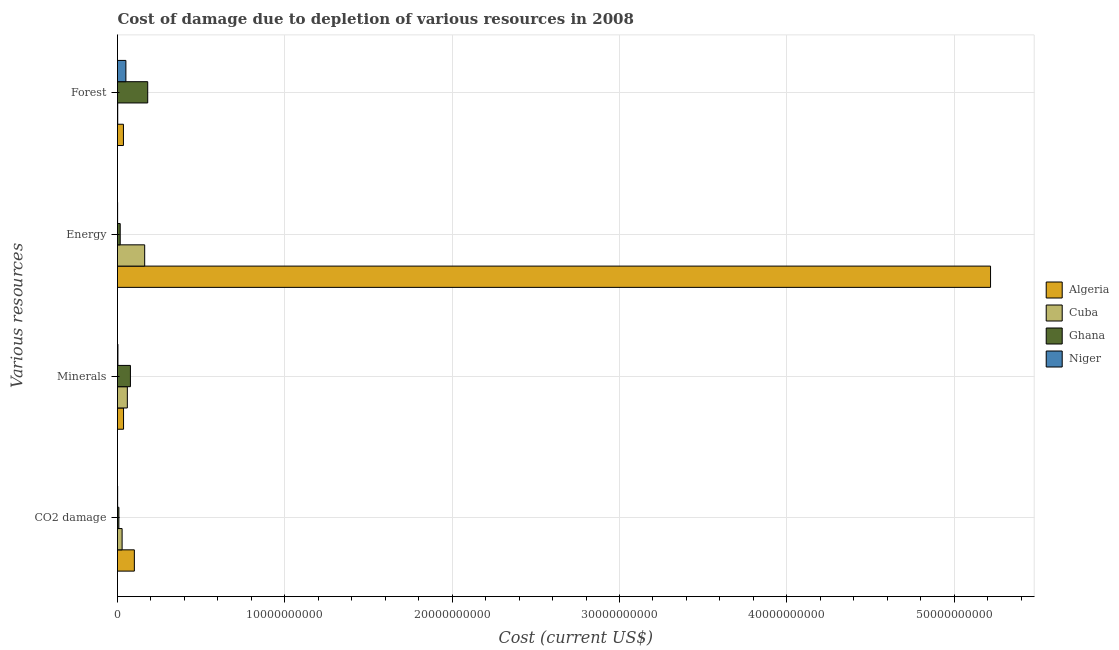How many different coloured bars are there?
Provide a succinct answer. 4. How many groups of bars are there?
Make the answer very short. 4. Are the number of bars on each tick of the Y-axis equal?
Your answer should be compact. Yes. How many bars are there on the 1st tick from the top?
Offer a terse response. 4. How many bars are there on the 2nd tick from the bottom?
Ensure brevity in your answer.  4. What is the label of the 2nd group of bars from the top?
Your answer should be very brief. Energy. What is the cost of damage due to depletion of coal in Algeria?
Provide a short and direct response. 1.01e+09. Across all countries, what is the maximum cost of damage due to depletion of energy?
Your response must be concise. 5.22e+1. Across all countries, what is the minimum cost of damage due to depletion of forests?
Your answer should be compact. 1.25e+07. In which country was the cost of damage due to depletion of energy maximum?
Offer a terse response. Algeria. In which country was the cost of damage due to depletion of energy minimum?
Offer a very short reply. Niger. What is the total cost of damage due to depletion of minerals in the graph?
Offer a very short reply. 1.75e+09. What is the difference between the cost of damage due to depletion of coal in Ghana and that in Cuba?
Provide a short and direct response. -1.92e+08. What is the difference between the cost of damage due to depletion of minerals in Ghana and the cost of damage due to depletion of energy in Niger?
Your answer should be compact. 7.66e+08. What is the average cost of damage due to depletion of minerals per country?
Give a very brief answer. 4.37e+08. What is the difference between the cost of damage due to depletion of minerals and cost of damage due to depletion of forests in Niger?
Give a very brief answer. -4.75e+08. In how many countries, is the cost of damage due to depletion of coal greater than 12000000000 US$?
Your answer should be compact. 0. What is the ratio of the cost of damage due to depletion of minerals in Algeria to that in Niger?
Give a very brief answer. 14.01. Is the cost of damage due to depletion of energy in Cuba less than that in Ghana?
Give a very brief answer. No. What is the difference between the highest and the second highest cost of damage due to depletion of forests?
Your answer should be very brief. 1.30e+09. What is the difference between the highest and the lowest cost of damage due to depletion of forests?
Offer a terse response. 1.79e+09. In how many countries, is the cost of damage due to depletion of minerals greater than the average cost of damage due to depletion of minerals taken over all countries?
Give a very brief answer. 2. Is the sum of the cost of damage due to depletion of coal in Ghana and Cuba greater than the maximum cost of damage due to depletion of energy across all countries?
Ensure brevity in your answer.  No. Is it the case that in every country, the sum of the cost of damage due to depletion of forests and cost of damage due to depletion of energy is greater than the sum of cost of damage due to depletion of minerals and cost of damage due to depletion of coal?
Your answer should be very brief. Yes. What does the 2nd bar from the top in CO2 damage represents?
Make the answer very short. Ghana. What does the 4th bar from the bottom in Minerals represents?
Provide a short and direct response. Niger. Is it the case that in every country, the sum of the cost of damage due to depletion of coal and cost of damage due to depletion of minerals is greater than the cost of damage due to depletion of energy?
Your response must be concise. No. How many countries are there in the graph?
Provide a succinct answer. 4. What is the difference between two consecutive major ticks on the X-axis?
Your answer should be very brief. 1.00e+1. Are the values on the major ticks of X-axis written in scientific E-notation?
Your answer should be compact. No. Does the graph contain any zero values?
Your answer should be very brief. No. Does the graph contain grids?
Offer a very short reply. Yes. Where does the legend appear in the graph?
Your answer should be compact. Center right. What is the title of the graph?
Offer a terse response. Cost of damage due to depletion of various resources in 2008 . What is the label or title of the X-axis?
Your response must be concise. Cost (current US$). What is the label or title of the Y-axis?
Ensure brevity in your answer.  Various resources. What is the Cost (current US$) in Algeria in CO2 damage?
Your answer should be compact. 1.01e+09. What is the Cost (current US$) of Cuba in CO2 damage?
Keep it short and to the point. 2.75e+08. What is the Cost (current US$) of Ghana in CO2 damage?
Provide a short and direct response. 8.25e+07. What is the Cost (current US$) of Niger in CO2 damage?
Offer a terse response. 8.27e+06. What is the Cost (current US$) of Algeria in Minerals?
Give a very brief answer. 3.61e+08. What is the Cost (current US$) in Cuba in Minerals?
Your answer should be very brief. 5.88e+08. What is the Cost (current US$) of Ghana in Minerals?
Your answer should be compact. 7.72e+08. What is the Cost (current US$) in Niger in Minerals?
Give a very brief answer. 2.58e+07. What is the Cost (current US$) of Algeria in Energy?
Provide a short and direct response. 5.22e+1. What is the Cost (current US$) of Cuba in Energy?
Your answer should be very brief. 1.62e+09. What is the Cost (current US$) of Ghana in Energy?
Provide a short and direct response. 1.61e+08. What is the Cost (current US$) of Niger in Energy?
Ensure brevity in your answer.  6.09e+06. What is the Cost (current US$) of Algeria in Forest?
Your response must be concise. 3.55e+08. What is the Cost (current US$) of Cuba in Forest?
Ensure brevity in your answer.  1.25e+07. What is the Cost (current US$) in Ghana in Forest?
Keep it short and to the point. 1.81e+09. What is the Cost (current US$) in Niger in Forest?
Your answer should be compact. 5.01e+08. Across all Various resources, what is the maximum Cost (current US$) of Algeria?
Your answer should be compact. 5.22e+1. Across all Various resources, what is the maximum Cost (current US$) in Cuba?
Provide a succinct answer. 1.62e+09. Across all Various resources, what is the maximum Cost (current US$) in Ghana?
Give a very brief answer. 1.81e+09. Across all Various resources, what is the maximum Cost (current US$) of Niger?
Ensure brevity in your answer.  5.01e+08. Across all Various resources, what is the minimum Cost (current US$) in Algeria?
Offer a very short reply. 3.55e+08. Across all Various resources, what is the minimum Cost (current US$) of Cuba?
Your answer should be very brief. 1.25e+07. Across all Various resources, what is the minimum Cost (current US$) in Ghana?
Your answer should be very brief. 8.25e+07. Across all Various resources, what is the minimum Cost (current US$) in Niger?
Offer a terse response. 6.09e+06. What is the total Cost (current US$) in Algeria in the graph?
Offer a very short reply. 5.39e+1. What is the total Cost (current US$) of Cuba in the graph?
Provide a succinct answer. 2.50e+09. What is the total Cost (current US$) of Ghana in the graph?
Keep it short and to the point. 2.82e+09. What is the total Cost (current US$) in Niger in the graph?
Make the answer very short. 5.41e+08. What is the difference between the Cost (current US$) of Algeria in CO2 damage and that in Minerals?
Your answer should be compact. 6.46e+08. What is the difference between the Cost (current US$) of Cuba in CO2 damage and that in Minerals?
Your response must be concise. -3.13e+08. What is the difference between the Cost (current US$) in Ghana in CO2 damage and that in Minerals?
Offer a very short reply. -6.90e+08. What is the difference between the Cost (current US$) of Niger in CO2 damage and that in Minerals?
Offer a very short reply. -1.75e+07. What is the difference between the Cost (current US$) of Algeria in CO2 damage and that in Energy?
Your answer should be very brief. -5.12e+1. What is the difference between the Cost (current US$) in Cuba in CO2 damage and that in Energy?
Your answer should be very brief. -1.35e+09. What is the difference between the Cost (current US$) of Ghana in CO2 damage and that in Energy?
Provide a succinct answer. -7.87e+07. What is the difference between the Cost (current US$) of Niger in CO2 damage and that in Energy?
Offer a very short reply. 2.19e+06. What is the difference between the Cost (current US$) in Algeria in CO2 damage and that in Forest?
Ensure brevity in your answer.  6.52e+08. What is the difference between the Cost (current US$) of Cuba in CO2 damage and that in Forest?
Ensure brevity in your answer.  2.62e+08. What is the difference between the Cost (current US$) of Ghana in CO2 damage and that in Forest?
Offer a very short reply. -1.72e+09. What is the difference between the Cost (current US$) of Niger in CO2 damage and that in Forest?
Your answer should be very brief. -4.93e+08. What is the difference between the Cost (current US$) in Algeria in Minerals and that in Energy?
Ensure brevity in your answer.  -5.18e+1. What is the difference between the Cost (current US$) of Cuba in Minerals and that in Energy?
Your response must be concise. -1.04e+09. What is the difference between the Cost (current US$) in Ghana in Minerals and that in Energy?
Provide a succinct answer. 6.11e+08. What is the difference between the Cost (current US$) of Niger in Minerals and that in Energy?
Your answer should be very brief. 1.97e+07. What is the difference between the Cost (current US$) in Algeria in Minerals and that in Forest?
Ensure brevity in your answer.  6.58e+06. What is the difference between the Cost (current US$) in Cuba in Minerals and that in Forest?
Make the answer very short. 5.75e+08. What is the difference between the Cost (current US$) in Ghana in Minerals and that in Forest?
Offer a very short reply. -1.03e+09. What is the difference between the Cost (current US$) of Niger in Minerals and that in Forest?
Provide a short and direct response. -4.75e+08. What is the difference between the Cost (current US$) in Algeria in Energy and that in Forest?
Your response must be concise. 5.18e+1. What is the difference between the Cost (current US$) in Cuba in Energy and that in Forest?
Give a very brief answer. 1.61e+09. What is the difference between the Cost (current US$) of Ghana in Energy and that in Forest?
Ensure brevity in your answer.  -1.64e+09. What is the difference between the Cost (current US$) of Niger in Energy and that in Forest?
Make the answer very short. -4.95e+08. What is the difference between the Cost (current US$) in Algeria in CO2 damage and the Cost (current US$) in Cuba in Minerals?
Your answer should be compact. 4.19e+08. What is the difference between the Cost (current US$) in Algeria in CO2 damage and the Cost (current US$) in Ghana in Minerals?
Offer a terse response. 2.34e+08. What is the difference between the Cost (current US$) of Algeria in CO2 damage and the Cost (current US$) of Niger in Minerals?
Provide a short and direct response. 9.81e+08. What is the difference between the Cost (current US$) of Cuba in CO2 damage and the Cost (current US$) of Ghana in Minerals?
Offer a terse response. -4.98e+08. What is the difference between the Cost (current US$) of Cuba in CO2 damage and the Cost (current US$) of Niger in Minerals?
Give a very brief answer. 2.49e+08. What is the difference between the Cost (current US$) in Ghana in CO2 damage and the Cost (current US$) in Niger in Minerals?
Your answer should be very brief. 5.67e+07. What is the difference between the Cost (current US$) in Algeria in CO2 damage and the Cost (current US$) in Cuba in Energy?
Ensure brevity in your answer.  -6.18e+08. What is the difference between the Cost (current US$) of Algeria in CO2 damage and the Cost (current US$) of Ghana in Energy?
Provide a succinct answer. 8.46e+08. What is the difference between the Cost (current US$) in Algeria in CO2 damage and the Cost (current US$) in Niger in Energy?
Make the answer very short. 1.00e+09. What is the difference between the Cost (current US$) of Cuba in CO2 damage and the Cost (current US$) of Ghana in Energy?
Provide a short and direct response. 1.14e+08. What is the difference between the Cost (current US$) in Cuba in CO2 damage and the Cost (current US$) in Niger in Energy?
Keep it short and to the point. 2.69e+08. What is the difference between the Cost (current US$) of Ghana in CO2 damage and the Cost (current US$) of Niger in Energy?
Keep it short and to the point. 7.64e+07. What is the difference between the Cost (current US$) of Algeria in CO2 damage and the Cost (current US$) of Cuba in Forest?
Keep it short and to the point. 9.94e+08. What is the difference between the Cost (current US$) of Algeria in CO2 damage and the Cost (current US$) of Ghana in Forest?
Your answer should be very brief. -7.99e+08. What is the difference between the Cost (current US$) in Algeria in CO2 damage and the Cost (current US$) in Niger in Forest?
Offer a very short reply. 5.06e+08. What is the difference between the Cost (current US$) of Cuba in CO2 damage and the Cost (current US$) of Ghana in Forest?
Provide a succinct answer. -1.53e+09. What is the difference between the Cost (current US$) of Cuba in CO2 damage and the Cost (current US$) of Niger in Forest?
Provide a short and direct response. -2.26e+08. What is the difference between the Cost (current US$) of Ghana in CO2 damage and the Cost (current US$) of Niger in Forest?
Keep it short and to the point. -4.18e+08. What is the difference between the Cost (current US$) of Algeria in Minerals and the Cost (current US$) of Cuba in Energy?
Your response must be concise. -1.26e+09. What is the difference between the Cost (current US$) in Algeria in Minerals and the Cost (current US$) in Ghana in Energy?
Provide a short and direct response. 2.00e+08. What is the difference between the Cost (current US$) of Algeria in Minerals and the Cost (current US$) of Niger in Energy?
Provide a short and direct response. 3.55e+08. What is the difference between the Cost (current US$) of Cuba in Minerals and the Cost (current US$) of Ghana in Energy?
Your response must be concise. 4.27e+08. What is the difference between the Cost (current US$) in Cuba in Minerals and the Cost (current US$) in Niger in Energy?
Your answer should be very brief. 5.82e+08. What is the difference between the Cost (current US$) of Ghana in Minerals and the Cost (current US$) of Niger in Energy?
Provide a short and direct response. 7.66e+08. What is the difference between the Cost (current US$) of Algeria in Minerals and the Cost (current US$) of Cuba in Forest?
Your answer should be very brief. 3.49e+08. What is the difference between the Cost (current US$) of Algeria in Minerals and the Cost (current US$) of Ghana in Forest?
Keep it short and to the point. -1.44e+09. What is the difference between the Cost (current US$) of Algeria in Minerals and the Cost (current US$) of Niger in Forest?
Provide a succinct answer. -1.40e+08. What is the difference between the Cost (current US$) in Cuba in Minerals and the Cost (current US$) in Ghana in Forest?
Your answer should be compact. -1.22e+09. What is the difference between the Cost (current US$) of Cuba in Minerals and the Cost (current US$) of Niger in Forest?
Give a very brief answer. 8.70e+07. What is the difference between the Cost (current US$) of Ghana in Minerals and the Cost (current US$) of Niger in Forest?
Provide a short and direct response. 2.72e+08. What is the difference between the Cost (current US$) in Algeria in Energy and the Cost (current US$) in Cuba in Forest?
Make the answer very short. 5.22e+1. What is the difference between the Cost (current US$) in Algeria in Energy and the Cost (current US$) in Ghana in Forest?
Provide a succinct answer. 5.04e+1. What is the difference between the Cost (current US$) in Algeria in Energy and the Cost (current US$) in Niger in Forest?
Provide a short and direct response. 5.17e+1. What is the difference between the Cost (current US$) in Cuba in Energy and the Cost (current US$) in Ghana in Forest?
Ensure brevity in your answer.  -1.81e+08. What is the difference between the Cost (current US$) in Cuba in Energy and the Cost (current US$) in Niger in Forest?
Make the answer very short. 1.12e+09. What is the difference between the Cost (current US$) in Ghana in Energy and the Cost (current US$) in Niger in Forest?
Your answer should be compact. -3.40e+08. What is the average Cost (current US$) in Algeria per Various resources?
Offer a terse response. 1.35e+1. What is the average Cost (current US$) in Cuba per Various resources?
Make the answer very short. 6.25e+08. What is the average Cost (current US$) of Ghana per Various resources?
Your answer should be very brief. 7.05e+08. What is the average Cost (current US$) in Niger per Various resources?
Ensure brevity in your answer.  1.35e+08. What is the difference between the Cost (current US$) in Algeria and Cost (current US$) in Cuba in CO2 damage?
Your answer should be very brief. 7.32e+08. What is the difference between the Cost (current US$) in Algeria and Cost (current US$) in Ghana in CO2 damage?
Give a very brief answer. 9.24e+08. What is the difference between the Cost (current US$) in Algeria and Cost (current US$) in Niger in CO2 damage?
Your answer should be compact. 9.99e+08. What is the difference between the Cost (current US$) in Cuba and Cost (current US$) in Ghana in CO2 damage?
Provide a short and direct response. 1.92e+08. What is the difference between the Cost (current US$) of Cuba and Cost (current US$) of Niger in CO2 damage?
Keep it short and to the point. 2.66e+08. What is the difference between the Cost (current US$) of Ghana and Cost (current US$) of Niger in CO2 damage?
Give a very brief answer. 7.42e+07. What is the difference between the Cost (current US$) in Algeria and Cost (current US$) in Cuba in Minerals?
Your answer should be compact. -2.27e+08. What is the difference between the Cost (current US$) in Algeria and Cost (current US$) in Ghana in Minerals?
Offer a very short reply. -4.11e+08. What is the difference between the Cost (current US$) of Algeria and Cost (current US$) of Niger in Minerals?
Your answer should be very brief. 3.35e+08. What is the difference between the Cost (current US$) of Cuba and Cost (current US$) of Ghana in Minerals?
Your answer should be very brief. -1.85e+08. What is the difference between the Cost (current US$) of Cuba and Cost (current US$) of Niger in Minerals?
Your response must be concise. 5.62e+08. What is the difference between the Cost (current US$) of Ghana and Cost (current US$) of Niger in Minerals?
Your answer should be compact. 7.47e+08. What is the difference between the Cost (current US$) of Algeria and Cost (current US$) of Cuba in Energy?
Your answer should be very brief. 5.06e+1. What is the difference between the Cost (current US$) in Algeria and Cost (current US$) in Ghana in Energy?
Provide a succinct answer. 5.20e+1. What is the difference between the Cost (current US$) of Algeria and Cost (current US$) of Niger in Energy?
Offer a terse response. 5.22e+1. What is the difference between the Cost (current US$) of Cuba and Cost (current US$) of Ghana in Energy?
Your answer should be compact. 1.46e+09. What is the difference between the Cost (current US$) of Cuba and Cost (current US$) of Niger in Energy?
Your answer should be compact. 1.62e+09. What is the difference between the Cost (current US$) of Ghana and Cost (current US$) of Niger in Energy?
Provide a succinct answer. 1.55e+08. What is the difference between the Cost (current US$) in Algeria and Cost (current US$) in Cuba in Forest?
Keep it short and to the point. 3.42e+08. What is the difference between the Cost (current US$) in Algeria and Cost (current US$) in Ghana in Forest?
Keep it short and to the point. -1.45e+09. What is the difference between the Cost (current US$) in Algeria and Cost (current US$) in Niger in Forest?
Your answer should be compact. -1.46e+08. What is the difference between the Cost (current US$) in Cuba and Cost (current US$) in Ghana in Forest?
Make the answer very short. -1.79e+09. What is the difference between the Cost (current US$) of Cuba and Cost (current US$) of Niger in Forest?
Your answer should be compact. -4.88e+08. What is the difference between the Cost (current US$) of Ghana and Cost (current US$) of Niger in Forest?
Your answer should be compact. 1.30e+09. What is the ratio of the Cost (current US$) in Algeria in CO2 damage to that in Minerals?
Your answer should be very brief. 2.79. What is the ratio of the Cost (current US$) of Cuba in CO2 damage to that in Minerals?
Ensure brevity in your answer.  0.47. What is the ratio of the Cost (current US$) of Ghana in CO2 damage to that in Minerals?
Your answer should be compact. 0.11. What is the ratio of the Cost (current US$) of Niger in CO2 damage to that in Minerals?
Your response must be concise. 0.32. What is the ratio of the Cost (current US$) of Algeria in CO2 damage to that in Energy?
Offer a very short reply. 0.02. What is the ratio of the Cost (current US$) of Cuba in CO2 damage to that in Energy?
Provide a succinct answer. 0.17. What is the ratio of the Cost (current US$) of Ghana in CO2 damage to that in Energy?
Offer a very short reply. 0.51. What is the ratio of the Cost (current US$) of Niger in CO2 damage to that in Energy?
Offer a terse response. 1.36. What is the ratio of the Cost (current US$) in Algeria in CO2 damage to that in Forest?
Provide a short and direct response. 2.84. What is the ratio of the Cost (current US$) of Cuba in CO2 damage to that in Forest?
Offer a very short reply. 21.91. What is the ratio of the Cost (current US$) in Ghana in CO2 damage to that in Forest?
Offer a very short reply. 0.05. What is the ratio of the Cost (current US$) of Niger in CO2 damage to that in Forest?
Give a very brief answer. 0.02. What is the ratio of the Cost (current US$) of Algeria in Minerals to that in Energy?
Your answer should be very brief. 0.01. What is the ratio of the Cost (current US$) of Cuba in Minerals to that in Energy?
Make the answer very short. 0.36. What is the ratio of the Cost (current US$) in Ghana in Minerals to that in Energy?
Your answer should be compact. 4.79. What is the ratio of the Cost (current US$) of Niger in Minerals to that in Energy?
Offer a terse response. 4.24. What is the ratio of the Cost (current US$) in Algeria in Minerals to that in Forest?
Provide a succinct answer. 1.02. What is the ratio of the Cost (current US$) in Cuba in Minerals to that in Forest?
Give a very brief answer. 46.88. What is the ratio of the Cost (current US$) of Ghana in Minerals to that in Forest?
Keep it short and to the point. 0.43. What is the ratio of the Cost (current US$) in Niger in Minerals to that in Forest?
Offer a very short reply. 0.05. What is the ratio of the Cost (current US$) in Algeria in Energy to that in Forest?
Your answer should be compact. 147.17. What is the ratio of the Cost (current US$) in Cuba in Energy to that in Forest?
Provide a succinct answer. 129.57. What is the ratio of the Cost (current US$) of Ghana in Energy to that in Forest?
Provide a succinct answer. 0.09. What is the ratio of the Cost (current US$) of Niger in Energy to that in Forest?
Keep it short and to the point. 0.01. What is the difference between the highest and the second highest Cost (current US$) of Algeria?
Your answer should be compact. 5.12e+1. What is the difference between the highest and the second highest Cost (current US$) of Cuba?
Provide a short and direct response. 1.04e+09. What is the difference between the highest and the second highest Cost (current US$) in Ghana?
Offer a terse response. 1.03e+09. What is the difference between the highest and the second highest Cost (current US$) in Niger?
Offer a terse response. 4.75e+08. What is the difference between the highest and the lowest Cost (current US$) in Algeria?
Your answer should be compact. 5.18e+1. What is the difference between the highest and the lowest Cost (current US$) in Cuba?
Your answer should be very brief. 1.61e+09. What is the difference between the highest and the lowest Cost (current US$) in Ghana?
Give a very brief answer. 1.72e+09. What is the difference between the highest and the lowest Cost (current US$) in Niger?
Keep it short and to the point. 4.95e+08. 